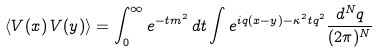<formula> <loc_0><loc_0><loc_500><loc_500>\langle V ( { x } ) \, V ( { y } ) \rangle = \int _ { 0 } ^ { \infty } e ^ { - t m ^ { 2 } } \, d t \int e ^ { i { q } ( { x } - { y } ) - \kappa ^ { 2 } t { q } ^ { 2 } } \frac { d ^ { N } { q } } { ( 2 \pi ) ^ { N } }</formula> 